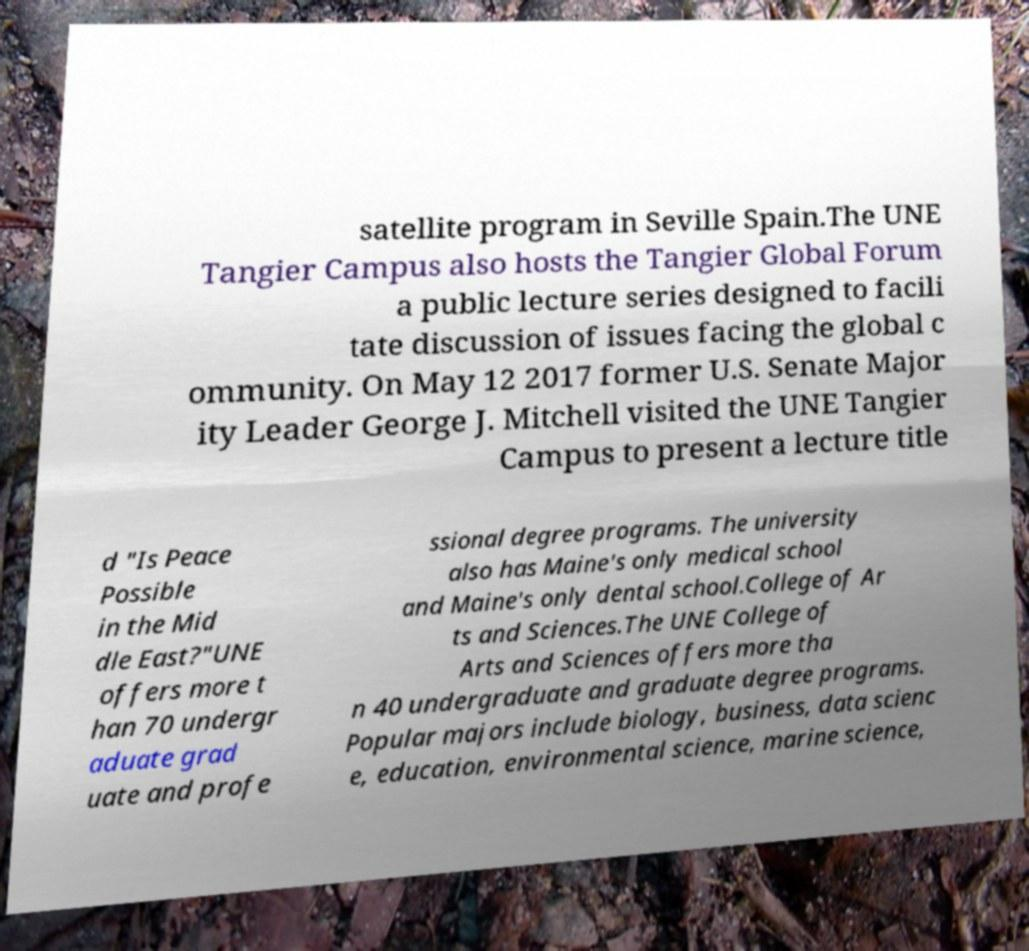Please read and relay the text visible in this image. What does it say? satellite program in Seville Spain.The UNE Tangier Campus also hosts the Tangier Global Forum a public lecture series designed to facili tate discussion of issues facing the global c ommunity. On May 12 2017 former U.S. Senate Major ity Leader George J. Mitchell visited the UNE Tangier Campus to present a lecture title d "Is Peace Possible in the Mid dle East?"UNE offers more t han 70 undergr aduate grad uate and profe ssional degree programs. The university also has Maine's only medical school and Maine's only dental school.College of Ar ts and Sciences.The UNE College of Arts and Sciences offers more tha n 40 undergraduate and graduate degree programs. Popular majors include biology, business, data scienc e, education, environmental science, marine science, 